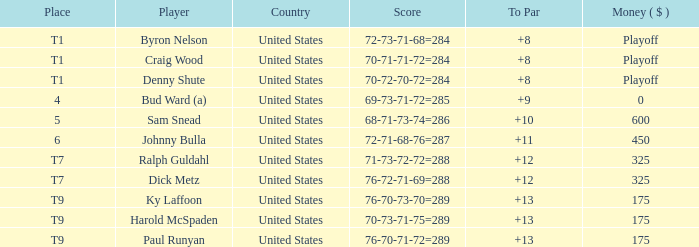What was the country for Sam Snead? United States. 